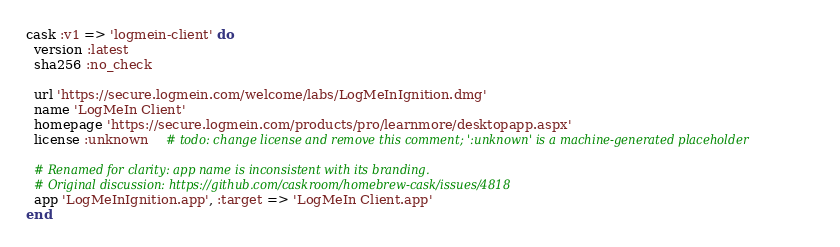<code> <loc_0><loc_0><loc_500><loc_500><_Ruby_>cask :v1 => 'logmein-client' do
  version :latest
  sha256 :no_check

  url 'https://secure.logmein.com/welcome/labs/LogMeInIgnition.dmg'
  name 'LogMeIn Client'
  homepage 'https://secure.logmein.com/products/pro/learnmore/desktopapp.aspx'
  license :unknown    # todo: change license and remove this comment; ':unknown' is a machine-generated placeholder

  # Renamed for clarity: app name is inconsistent with its branding.
  # Original discussion: https://github.com/caskroom/homebrew-cask/issues/4818
  app 'LogMeInIgnition.app', :target => 'LogMeIn Client.app'
end
</code> 